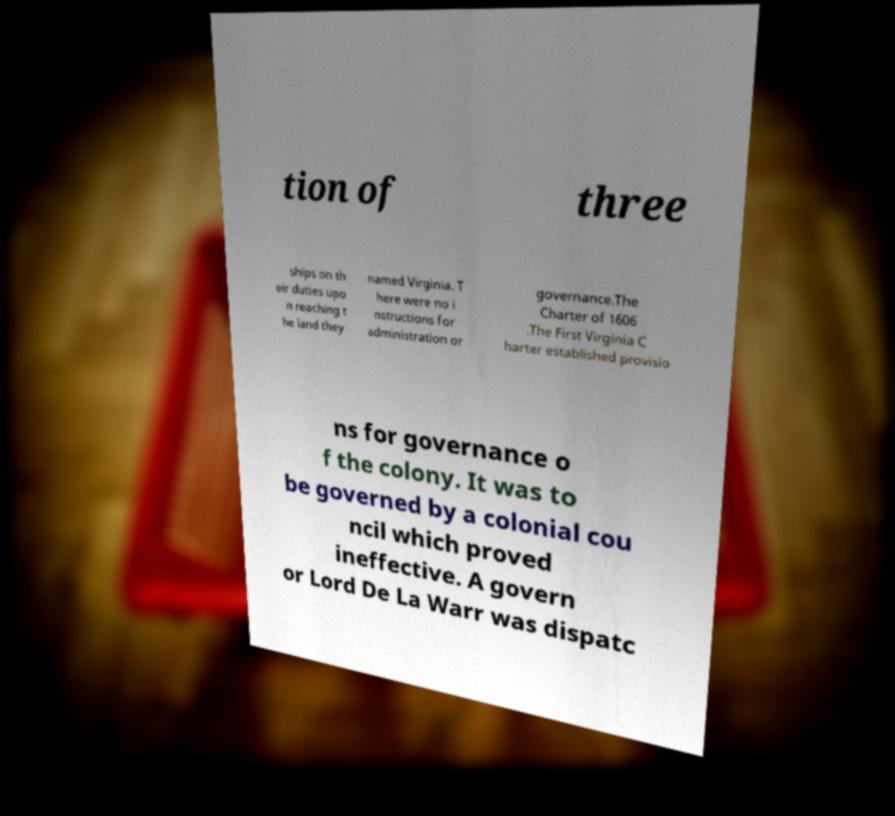Can you read and provide the text displayed in the image?This photo seems to have some interesting text. Can you extract and type it out for me? tion of three ships on th eir duties upo n reaching t he land they named Virginia. T here were no i nstructions for administration or governance.The Charter of 1606 .The First Virginia C harter established provisio ns for governance o f the colony. It was to be governed by a colonial cou ncil which proved ineffective. A govern or Lord De La Warr was dispatc 